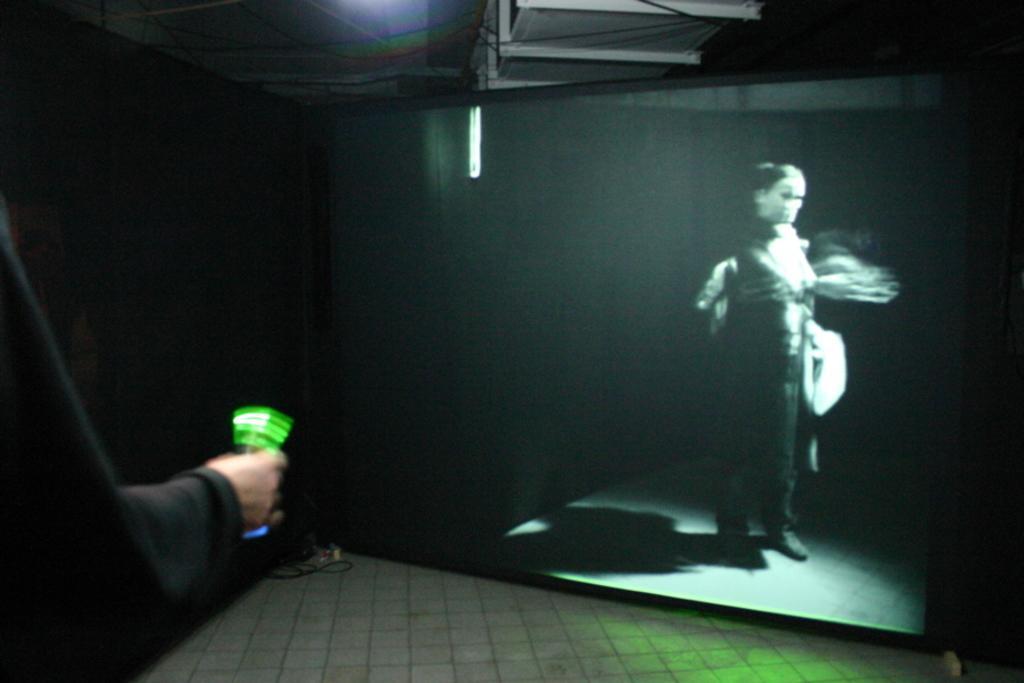Describe this image in one or two sentences. In this picture I can see a person's hand in front and I see that, the person is holding a green color thing and I can see the path on the bottom side of this picture. In the background I can see the screen, on which I can see a person and a light. 